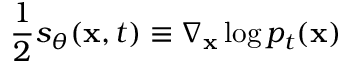<formula> <loc_0><loc_0><loc_500><loc_500>\frac { 1 } { 2 } s _ { \theta } ( x , t ) \equiv \nabla _ { x } \log p _ { t } ( x )</formula> 